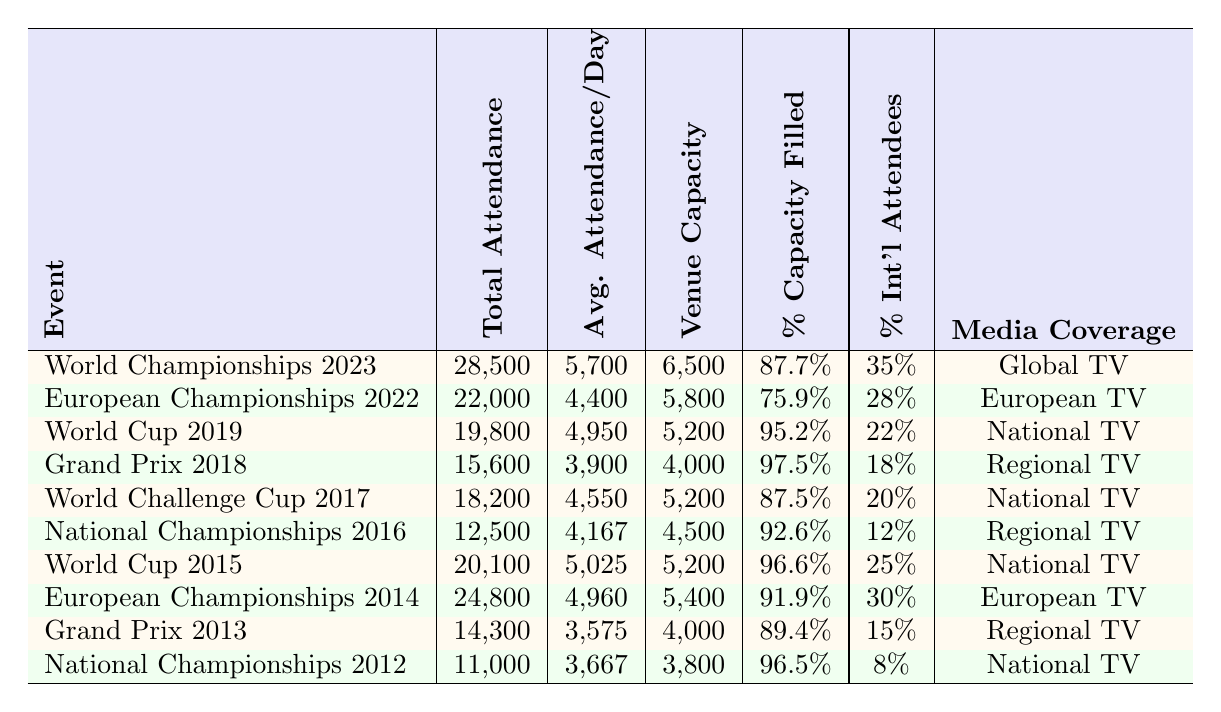What was the total attendance for the World Rhythmic Gymnastics Championships in 2023? The total attendance figure for the event listed in the table is directly shown next to it. For the World Rhythmic Gymnastics Championships 2023, the total attendance is 28,500.
Answer: 28,500 What was the average attendance per day for the European Rhythmic Gymnastics Championships held in 2022? The average attendance per day is provided in the table for each event. For the European Championships 2022, this figure is 4,400.
Answer: 4,400 Which event had the highest percentage of venue capacity filled? By comparing the percentage capacity filled for each event listed, it is evident that the Grand Prix 2018 had the highest percentage at 97.5%.
Answer: 97.5% What was the venue capacity for the Spanish Rhythmic Gymnastics National Championships in 2016? The venue capacity figure for each event is available in the corresponding row of the table. For the National Championships in 2016, the venue capacity is 4,500.
Answer: 4,500 Calculate the average total attendance across all events listed in the table. To find the average, sum all total attendance figures: 28,500 + 22,000 + 19,800 + 15,600 + 18,200 + 12,500 + 20,100 + 24,800 + 14,300 + 11,000 =  256,800. Divide this sum by the number of events (10); thus, the average is 256,800 / 10 = 25,680.
Answer: 25,680 Did any event have international attendee percentages above 30%? By checking the percentage of international attendees for each event, it is confirmed that the European Championships 2014 had 30%, which is the maximum but does not exceed this value. Thus, no event had international attendee percentages above 30%.
Answer: No What is the total attendance for the events held in Guadalajara? The events held in Guadalajara listed are the European Championships 2022, the World Cup 2019, and the World Challenge Cup 2017. Summing their attendance gives: 22,000 + 19,800 + 18,200 = 60,000 for the total attendance of these events combined.
Answer: 60,000 Which event had the lowest average attendance per day? By reviewing the average attendance per day for each event, the Spanish Rhythmic Gymnastics National Championships 2012 shows the lowest average at 3,667.
Answer: 3,667 What was the media coverage type for the World Cup 2015? The media coverage for the World Cup 2015 is specified in the table, showing it had "National TV" coverage.
Answer: National TV How does the percentage capacity filled of the Rhythmic Gymnastics Grand Prix 2013 compare to the Rhythmic Gymnastics World Challenge Cup 2017? According to the table, the Grand Prix 2013 was filled to 89.4%, while the World Challenge Cup 2017 was filled to 87.5%. The Grand Prix 2013 had a higher percentage of venue capacity filled.
Answer: Grand Prix 2013 had a higher percentage 